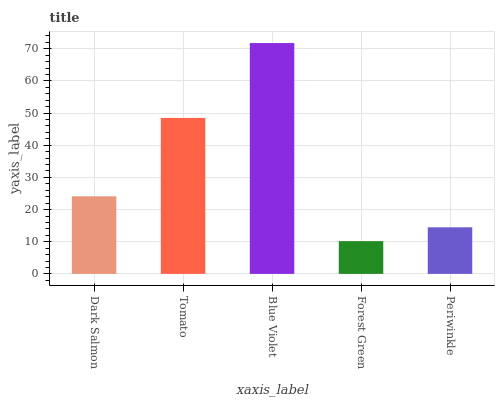Is Forest Green the minimum?
Answer yes or no. Yes. Is Blue Violet the maximum?
Answer yes or no. Yes. Is Tomato the minimum?
Answer yes or no. No. Is Tomato the maximum?
Answer yes or no. No. Is Tomato greater than Dark Salmon?
Answer yes or no. Yes. Is Dark Salmon less than Tomato?
Answer yes or no. Yes. Is Dark Salmon greater than Tomato?
Answer yes or no. No. Is Tomato less than Dark Salmon?
Answer yes or no. No. Is Dark Salmon the high median?
Answer yes or no. Yes. Is Dark Salmon the low median?
Answer yes or no. Yes. Is Forest Green the high median?
Answer yes or no. No. Is Forest Green the low median?
Answer yes or no. No. 